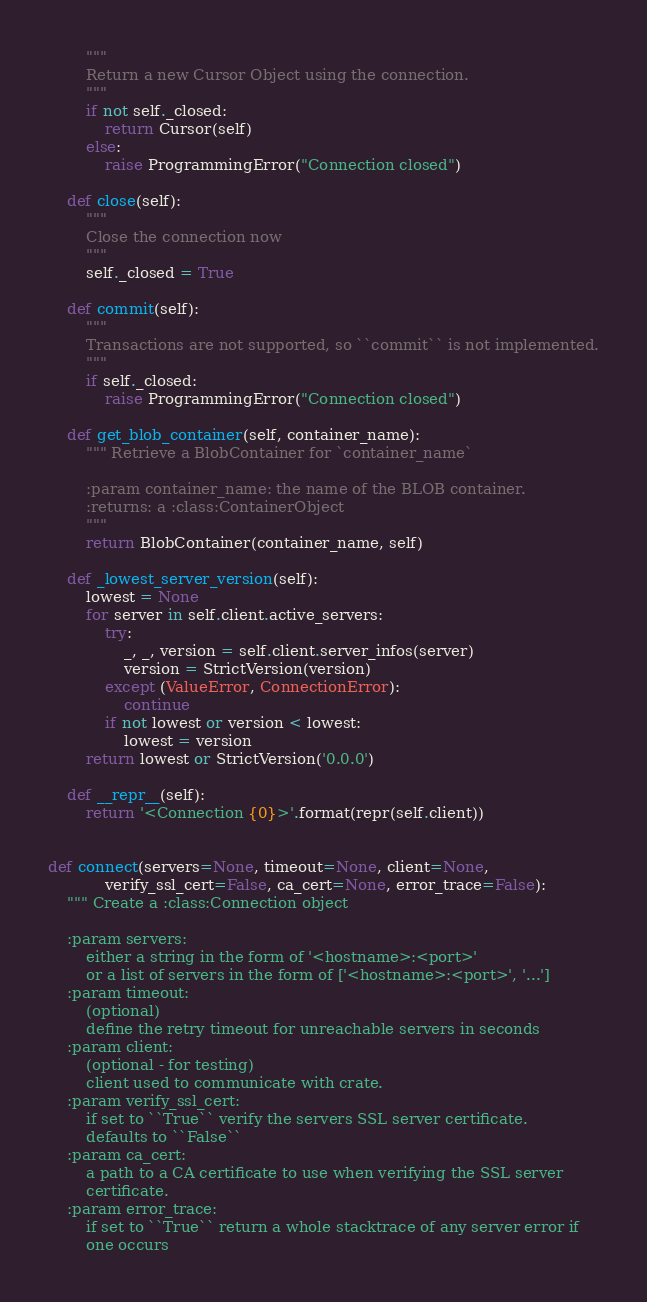<code> <loc_0><loc_0><loc_500><loc_500><_Python_>        """
        Return a new Cursor Object using the connection.
        """
        if not self._closed:
            return Cursor(self)
        else:
            raise ProgrammingError("Connection closed")

    def close(self):
        """
        Close the connection now
        """
        self._closed = True

    def commit(self):
        """
        Transactions are not supported, so ``commit`` is not implemented.
        """
        if self._closed:
            raise ProgrammingError("Connection closed")

    def get_blob_container(self, container_name):
        """ Retrieve a BlobContainer for `container_name`

        :param container_name: the name of the BLOB container.
        :returns: a :class:ContainerObject
        """
        return BlobContainer(container_name, self)

    def _lowest_server_version(self):
        lowest = None
        for server in self.client.active_servers:
            try:
                _, _, version = self.client.server_infos(server)
                version = StrictVersion(version)
            except (ValueError, ConnectionError):
                continue
            if not lowest or version < lowest:
                lowest = version
        return lowest or StrictVersion('0.0.0')

    def __repr__(self):
        return '<Connection {0}>'.format(repr(self.client))


def connect(servers=None, timeout=None, client=None,
            verify_ssl_cert=False, ca_cert=None, error_trace=False):
    """ Create a :class:Connection object

    :param servers:
        either a string in the form of '<hostname>:<port>'
        or a list of servers in the form of ['<hostname>:<port>', '...']
    :param timeout:
        (optional)
        define the retry timeout for unreachable servers in seconds
    :param client:
        (optional - for testing)
        client used to communicate with crate.
    :param verify_ssl_cert:
        if set to ``True`` verify the servers SSL server certificate.
        defaults to ``False``
    :param ca_cert:
        a path to a CA certificate to use when verifying the SSL server
        certificate.
    :param error_trace:
        if set to ``True`` return a whole stacktrace of any server error if
        one occurs
</code> 